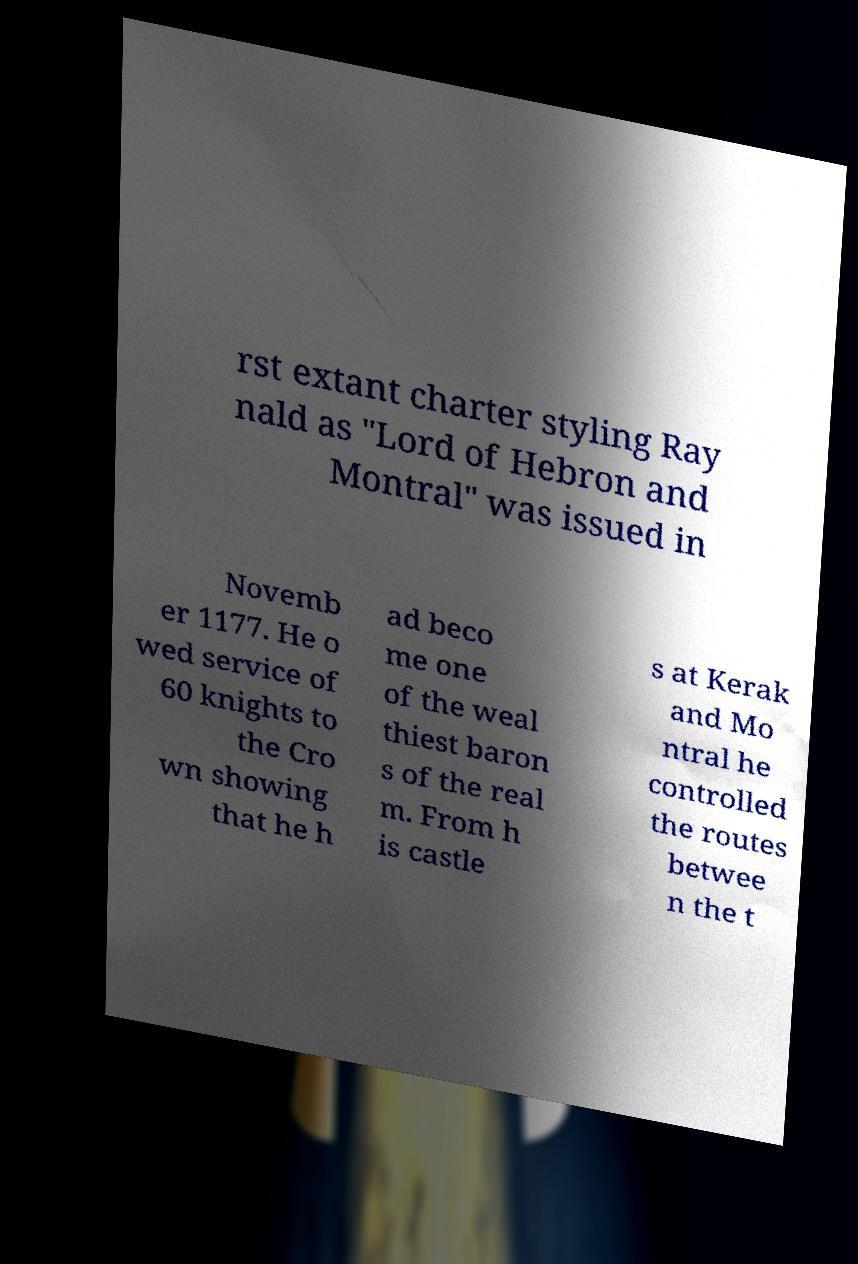Could you extract and type out the text from this image? rst extant charter styling Ray nald as "Lord of Hebron and Montral" was issued in Novemb er 1177. He o wed service of 60 knights to the Cro wn showing that he h ad beco me one of the weal thiest baron s of the real m. From h is castle s at Kerak and Mo ntral he controlled the routes betwee n the t 